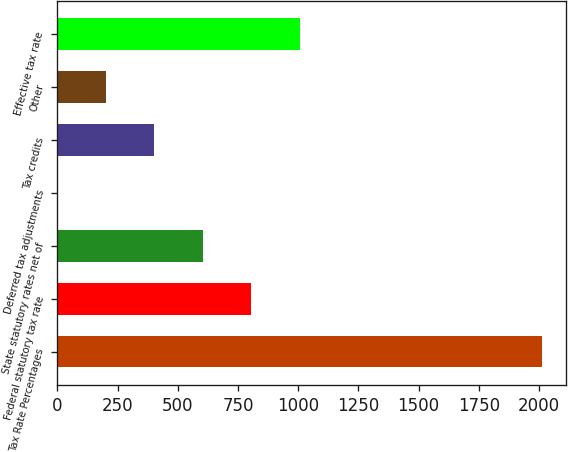Convert chart to OTSL. <chart><loc_0><loc_0><loc_500><loc_500><bar_chart><fcel>Tax Rate Percentages<fcel>Federal statutory tax rate<fcel>State statutory rates net of<fcel>Deferred tax adjustments<fcel>Tax credits<fcel>Other<fcel>Effective tax rate<nl><fcel>2012<fcel>804.86<fcel>603.67<fcel>0.1<fcel>402.48<fcel>201.29<fcel>1006.05<nl></chart> 